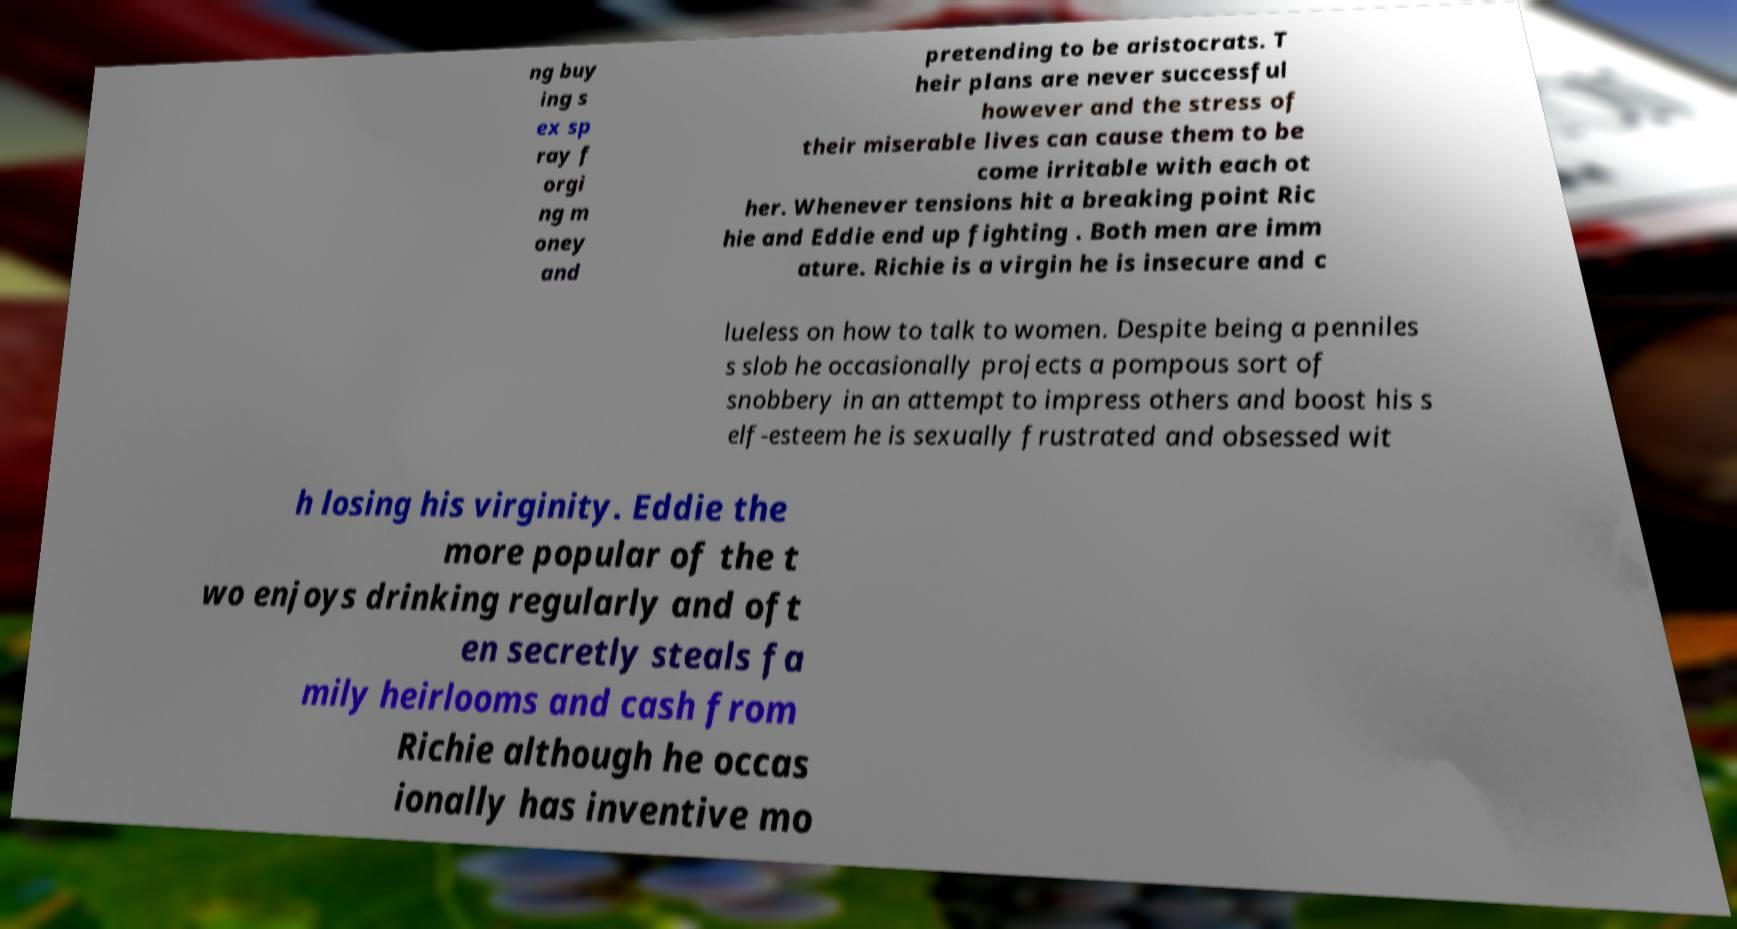Could you assist in decoding the text presented in this image and type it out clearly? ng buy ing s ex sp ray f orgi ng m oney and pretending to be aristocrats. T heir plans are never successful however and the stress of their miserable lives can cause them to be come irritable with each ot her. Whenever tensions hit a breaking point Ric hie and Eddie end up fighting . Both men are imm ature. Richie is a virgin he is insecure and c lueless on how to talk to women. Despite being a penniles s slob he occasionally projects a pompous sort of snobbery in an attempt to impress others and boost his s elf-esteem he is sexually frustrated and obsessed wit h losing his virginity. Eddie the more popular of the t wo enjoys drinking regularly and oft en secretly steals fa mily heirlooms and cash from Richie although he occas ionally has inventive mo 